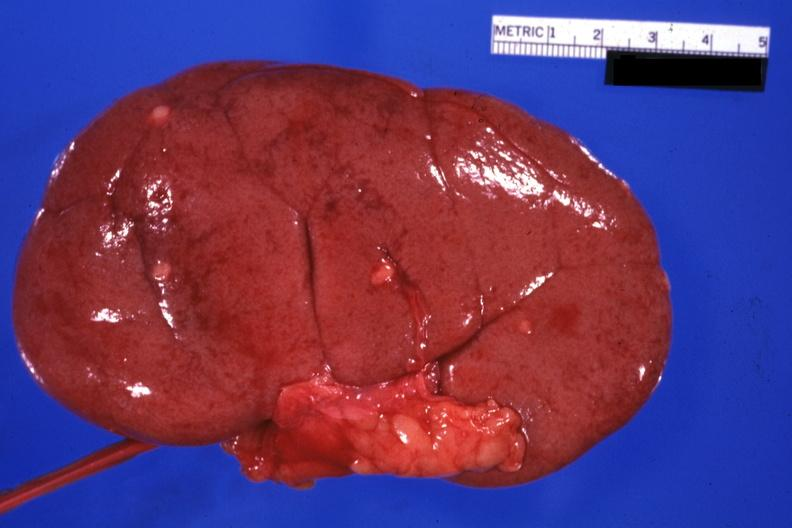where is this?
Answer the question using a single word or phrase. Urinary 